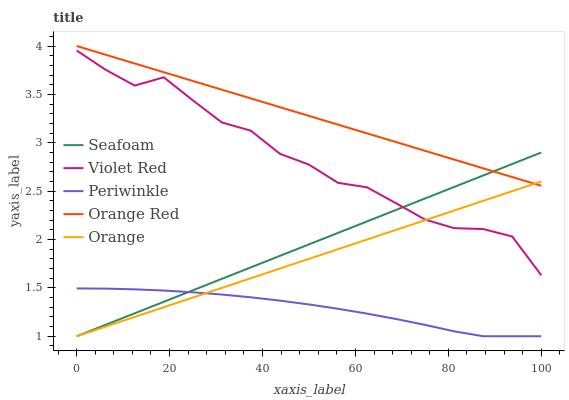Does Periwinkle have the minimum area under the curve?
Answer yes or no. Yes. Does Orange Red have the maximum area under the curve?
Answer yes or no. Yes. Does Violet Red have the minimum area under the curve?
Answer yes or no. No. Does Violet Red have the maximum area under the curve?
Answer yes or no. No. Is Orange the smoothest?
Answer yes or no. Yes. Is Violet Red the roughest?
Answer yes or no. Yes. Is Periwinkle the smoothest?
Answer yes or no. No. Is Periwinkle the roughest?
Answer yes or no. No. Does Orange have the lowest value?
Answer yes or no. Yes. Does Violet Red have the lowest value?
Answer yes or no. No. Does Orange Red have the highest value?
Answer yes or no. Yes. Does Violet Red have the highest value?
Answer yes or no. No. Is Violet Red less than Orange Red?
Answer yes or no. Yes. Is Violet Red greater than Periwinkle?
Answer yes or no. Yes. Does Violet Red intersect Orange?
Answer yes or no. Yes. Is Violet Red less than Orange?
Answer yes or no. No. Is Violet Red greater than Orange?
Answer yes or no. No. Does Violet Red intersect Orange Red?
Answer yes or no. No. 